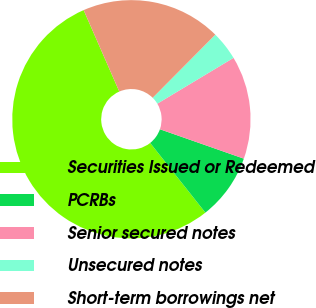Convert chart. <chart><loc_0><loc_0><loc_500><loc_500><pie_chart><fcel>Securities Issued or Redeemed<fcel>PCRBs<fcel>Senior secured notes<fcel>Unsecured notes<fcel>Short-term borrowings net<nl><fcel>54.1%<fcel>8.97%<fcel>13.98%<fcel>3.95%<fcel>19.0%<nl></chart> 